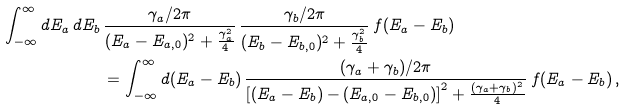Convert formula to latex. <formula><loc_0><loc_0><loc_500><loc_500>\int _ { - \infty } ^ { \infty } d E _ { a } \, d E _ { b } \, & \frac { \gamma _ { a } / 2 \pi } { ( E _ { a } - E _ { a , 0 } ) ^ { 2 } + \frac { \gamma _ { a } ^ { 2 } } { 4 } } \, \frac { \gamma _ { b } / 2 \pi } { ( E _ { b } - E _ { b , 0 } ) ^ { 2 } + \frac { \gamma _ { b } ^ { 2 } } { 4 } } \, f ( E _ { a } - E _ { b } ) \\ & = \int _ { - \infty } ^ { \infty } d ( E _ { a } - E _ { b } ) \, \frac { ( \gamma _ { a } + \gamma _ { b } ) / 2 \pi } { \left [ ( E _ { a } - E _ { b } ) - ( E _ { a , 0 } - E _ { b , 0 } ) \right ] ^ { 2 } + \frac { ( \gamma _ { a } + \gamma _ { b } ) ^ { 2 } } { 4 } } \, f ( E _ { a } - E _ { b } ) \, ,</formula> 